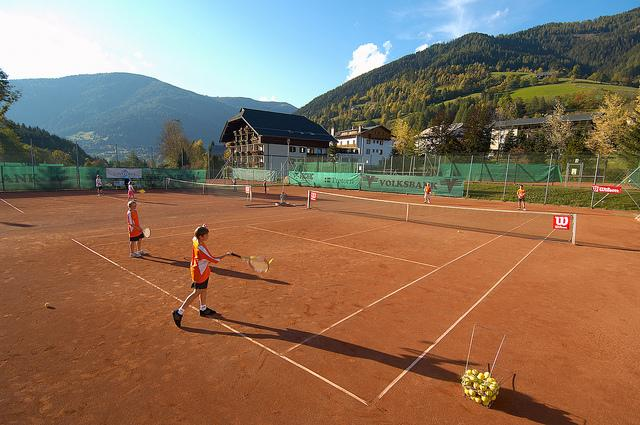What event is being carried out?

Choices:
A) tennis training
B) tennis competition
C) badminton training
D) badminton competition tennis training 